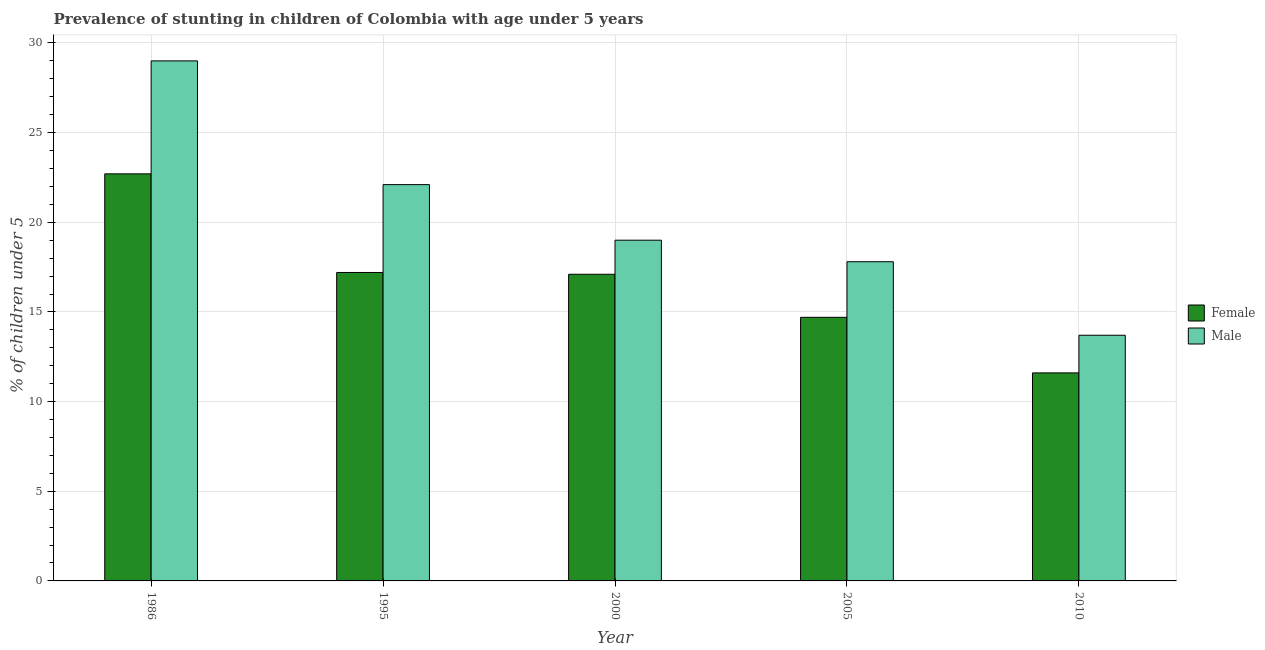How many different coloured bars are there?
Your answer should be very brief. 2. How many groups of bars are there?
Offer a terse response. 5. Are the number of bars per tick equal to the number of legend labels?
Give a very brief answer. Yes. Are the number of bars on each tick of the X-axis equal?
Your answer should be compact. Yes. How many bars are there on the 5th tick from the left?
Offer a terse response. 2. Across all years, what is the maximum percentage of stunted male children?
Your response must be concise. 29. Across all years, what is the minimum percentage of stunted female children?
Make the answer very short. 11.6. In which year was the percentage of stunted male children maximum?
Offer a terse response. 1986. What is the total percentage of stunted female children in the graph?
Give a very brief answer. 83.3. What is the difference between the percentage of stunted female children in 1986 and that in 2000?
Give a very brief answer. 5.6. What is the difference between the percentage of stunted female children in 1995 and the percentage of stunted male children in 2010?
Ensure brevity in your answer.  5.6. What is the average percentage of stunted female children per year?
Make the answer very short. 16.66. In the year 1995, what is the difference between the percentage of stunted male children and percentage of stunted female children?
Ensure brevity in your answer.  0. What is the ratio of the percentage of stunted male children in 1995 to that in 2010?
Make the answer very short. 1.61. Is the percentage of stunted male children in 1986 less than that in 2010?
Provide a succinct answer. No. Is the difference between the percentage of stunted male children in 1986 and 1995 greater than the difference between the percentage of stunted female children in 1986 and 1995?
Provide a short and direct response. No. What is the difference between the highest and the second highest percentage of stunted male children?
Your response must be concise. 6.9. What is the difference between the highest and the lowest percentage of stunted male children?
Ensure brevity in your answer.  15.3. Is the sum of the percentage of stunted female children in 1986 and 2005 greater than the maximum percentage of stunted male children across all years?
Provide a short and direct response. Yes. What does the 1st bar from the right in 1986 represents?
Provide a short and direct response. Male. Are all the bars in the graph horizontal?
Your response must be concise. No. Are the values on the major ticks of Y-axis written in scientific E-notation?
Your answer should be very brief. No. How many legend labels are there?
Keep it short and to the point. 2. How are the legend labels stacked?
Your answer should be compact. Vertical. What is the title of the graph?
Ensure brevity in your answer.  Prevalence of stunting in children of Colombia with age under 5 years. What is the label or title of the Y-axis?
Your answer should be very brief.  % of children under 5. What is the  % of children under 5 of Female in 1986?
Offer a very short reply. 22.7. What is the  % of children under 5 of Male in 1986?
Offer a very short reply. 29. What is the  % of children under 5 in Female in 1995?
Offer a very short reply. 17.2. What is the  % of children under 5 of Male in 1995?
Your response must be concise. 22.1. What is the  % of children under 5 in Female in 2000?
Your response must be concise. 17.1. What is the  % of children under 5 in Male in 2000?
Offer a very short reply. 19. What is the  % of children under 5 in Female in 2005?
Give a very brief answer. 14.7. What is the  % of children under 5 in Male in 2005?
Provide a short and direct response. 17.8. What is the  % of children under 5 of Female in 2010?
Give a very brief answer. 11.6. What is the  % of children under 5 of Male in 2010?
Provide a succinct answer. 13.7. Across all years, what is the maximum  % of children under 5 in Female?
Provide a succinct answer. 22.7. Across all years, what is the maximum  % of children under 5 of Male?
Provide a short and direct response. 29. Across all years, what is the minimum  % of children under 5 of Female?
Offer a very short reply. 11.6. Across all years, what is the minimum  % of children under 5 in Male?
Make the answer very short. 13.7. What is the total  % of children under 5 in Female in the graph?
Offer a very short reply. 83.3. What is the total  % of children under 5 of Male in the graph?
Give a very brief answer. 101.6. What is the difference between the  % of children under 5 of Female in 1986 and that in 1995?
Offer a very short reply. 5.5. What is the difference between the  % of children under 5 of Female in 1986 and that in 2010?
Offer a very short reply. 11.1. What is the difference between the  % of children under 5 in Male in 1986 and that in 2010?
Make the answer very short. 15.3. What is the difference between the  % of children under 5 in Male in 1995 and that in 2000?
Offer a very short reply. 3.1. What is the difference between the  % of children under 5 in Male in 1995 and that in 2010?
Offer a very short reply. 8.4. What is the difference between the  % of children under 5 of Female in 2000 and that in 2010?
Make the answer very short. 5.5. What is the difference between the  % of children under 5 of Male in 2000 and that in 2010?
Offer a terse response. 5.3. What is the difference between the  % of children under 5 of Female in 2005 and that in 2010?
Offer a terse response. 3.1. What is the difference between the  % of children under 5 of Male in 2005 and that in 2010?
Your answer should be very brief. 4.1. What is the difference between the  % of children under 5 in Female in 1986 and the  % of children under 5 in Male in 1995?
Your answer should be very brief. 0.6. What is the difference between the  % of children under 5 in Female in 1986 and the  % of children under 5 in Male in 2000?
Make the answer very short. 3.7. What is the difference between the  % of children under 5 in Female in 1986 and the  % of children under 5 in Male in 2005?
Provide a short and direct response. 4.9. What is the difference between the  % of children under 5 in Female in 1986 and the  % of children under 5 in Male in 2010?
Offer a very short reply. 9. What is the difference between the  % of children under 5 of Female in 1995 and the  % of children under 5 of Male in 2010?
Offer a very short reply. 3.5. What is the difference between the  % of children under 5 of Female in 2000 and the  % of children under 5 of Male in 2010?
Keep it short and to the point. 3.4. What is the difference between the  % of children under 5 in Female in 2005 and the  % of children under 5 in Male in 2010?
Provide a short and direct response. 1. What is the average  % of children under 5 of Female per year?
Provide a short and direct response. 16.66. What is the average  % of children under 5 of Male per year?
Your answer should be very brief. 20.32. In the year 1995, what is the difference between the  % of children under 5 of Female and  % of children under 5 of Male?
Your response must be concise. -4.9. In the year 2005, what is the difference between the  % of children under 5 in Female and  % of children under 5 in Male?
Offer a very short reply. -3.1. In the year 2010, what is the difference between the  % of children under 5 of Female and  % of children under 5 of Male?
Ensure brevity in your answer.  -2.1. What is the ratio of the  % of children under 5 of Female in 1986 to that in 1995?
Offer a terse response. 1.32. What is the ratio of the  % of children under 5 of Male in 1986 to that in 1995?
Your response must be concise. 1.31. What is the ratio of the  % of children under 5 in Female in 1986 to that in 2000?
Your answer should be compact. 1.33. What is the ratio of the  % of children under 5 in Male in 1986 to that in 2000?
Your response must be concise. 1.53. What is the ratio of the  % of children under 5 in Female in 1986 to that in 2005?
Your answer should be very brief. 1.54. What is the ratio of the  % of children under 5 of Male in 1986 to that in 2005?
Your answer should be compact. 1.63. What is the ratio of the  % of children under 5 in Female in 1986 to that in 2010?
Your response must be concise. 1.96. What is the ratio of the  % of children under 5 of Male in 1986 to that in 2010?
Offer a very short reply. 2.12. What is the ratio of the  % of children under 5 in Male in 1995 to that in 2000?
Your response must be concise. 1.16. What is the ratio of the  % of children under 5 of Female in 1995 to that in 2005?
Offer a very short reply. 1.17. What is the ratio of the  % of children under 5 of Male in 1995 to that in 2005?
Provide a short and direct response. 1.24. What is the ratio of the  % of children under 5 in Female in 1995 to that in 2010?
Your answer should be very brief. 1.48. What is the ratio of the  % of children under 5 in Male in 1995 to that in 2010?
Your response must be concise. 1.61. What is the ratio of the  % of children under 5 of Female in 2000 to that in 2005?
Offer a terse response. 1.16. What is the ratio of the  % of children under 5 in Male in 2000 to that in 2005?
Your response must be concise. 1.07. What is the ratio of the  % of children under 5 of Female in 2000 to that in 2010?
Ensure brevity in your answer.  1.47. What is the ratio of the  % of children under 5 of Male in 2000 to that in 2010?
Ensure brevity in your answer.  1.39. What is the ratio of the  % of children under 5 in Female in 2005 to that in 2010?
Your answer should be compact. 1.27. What is the ratio of the  % of children under 5 in Male in 2005 to that in 2010?
Your answer should be very brief. 1.3. What is the difference between the highest and the second highest  % of children under 5 in Female?
Make the answer very short. 5.5. What is the difference between the highest and the lowest  % of children under 5 in Female?
Your answer should be very brief. 11.1. 